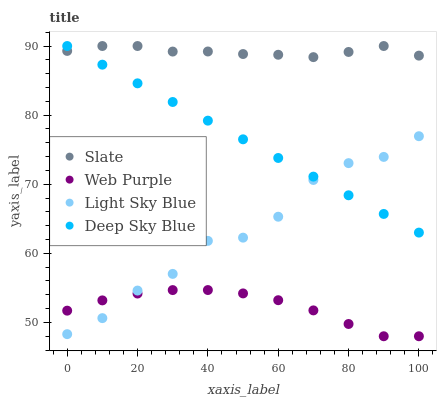Does Web Purple have the minimum area under the curve?
Answer yes or no. Yes. Does Slate have the maximum area under the curve?
Answer yes or no. Yes. Does Light Sky Blue have the minimum area under the curve?
Answer yes or no. No. Does Light Sky Blue have the maximum area under the curve?
Answer yes or no. No. Is Deep Sky Blue the smoothest?
Answer yes or no. Yes. Is Light Sky Blue the roughest?
Answer yes or no. Yes. Is Web Purple the smoothest?
Answer yes or no. No. Is Web Purple the roughest?
Answer yes or no. No. Does Web Purple have the lowest value?
Answer yes or no. Yes. Does Light Sky Blue have the lowest value?
Answer yes or no. No. Does Deep Sky Blue have the highest value?
Answer yes or no. Yes. Does Light Sky Blue have the highest value?
Answer yes or no. No. Is Web Purple less than Slate?
Answer yes or no. Yes. Is Slate greater than Light Sky Blue?
Answer yes or no. Yes. Does Web Purple intersect Light Sky Blue?
Answer yes or no. Yes. Is Web Purple less than Light Sky Blue?
Answer yes or no. No. Is Web Purple greater than Light Sky Blue?
Answer yes or no. No. Does Web Purple intersect Slate?
Answer yes or no. No. 